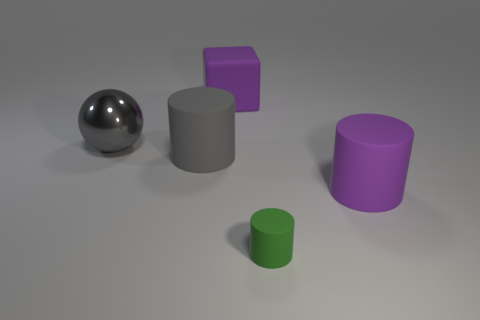Can you tell me the colors of the objects shown in the image? Certainly! In the image, there are objects in four different colors: a silver sphere, a purple cube, a purple cylinder, and a small green cylinder. 